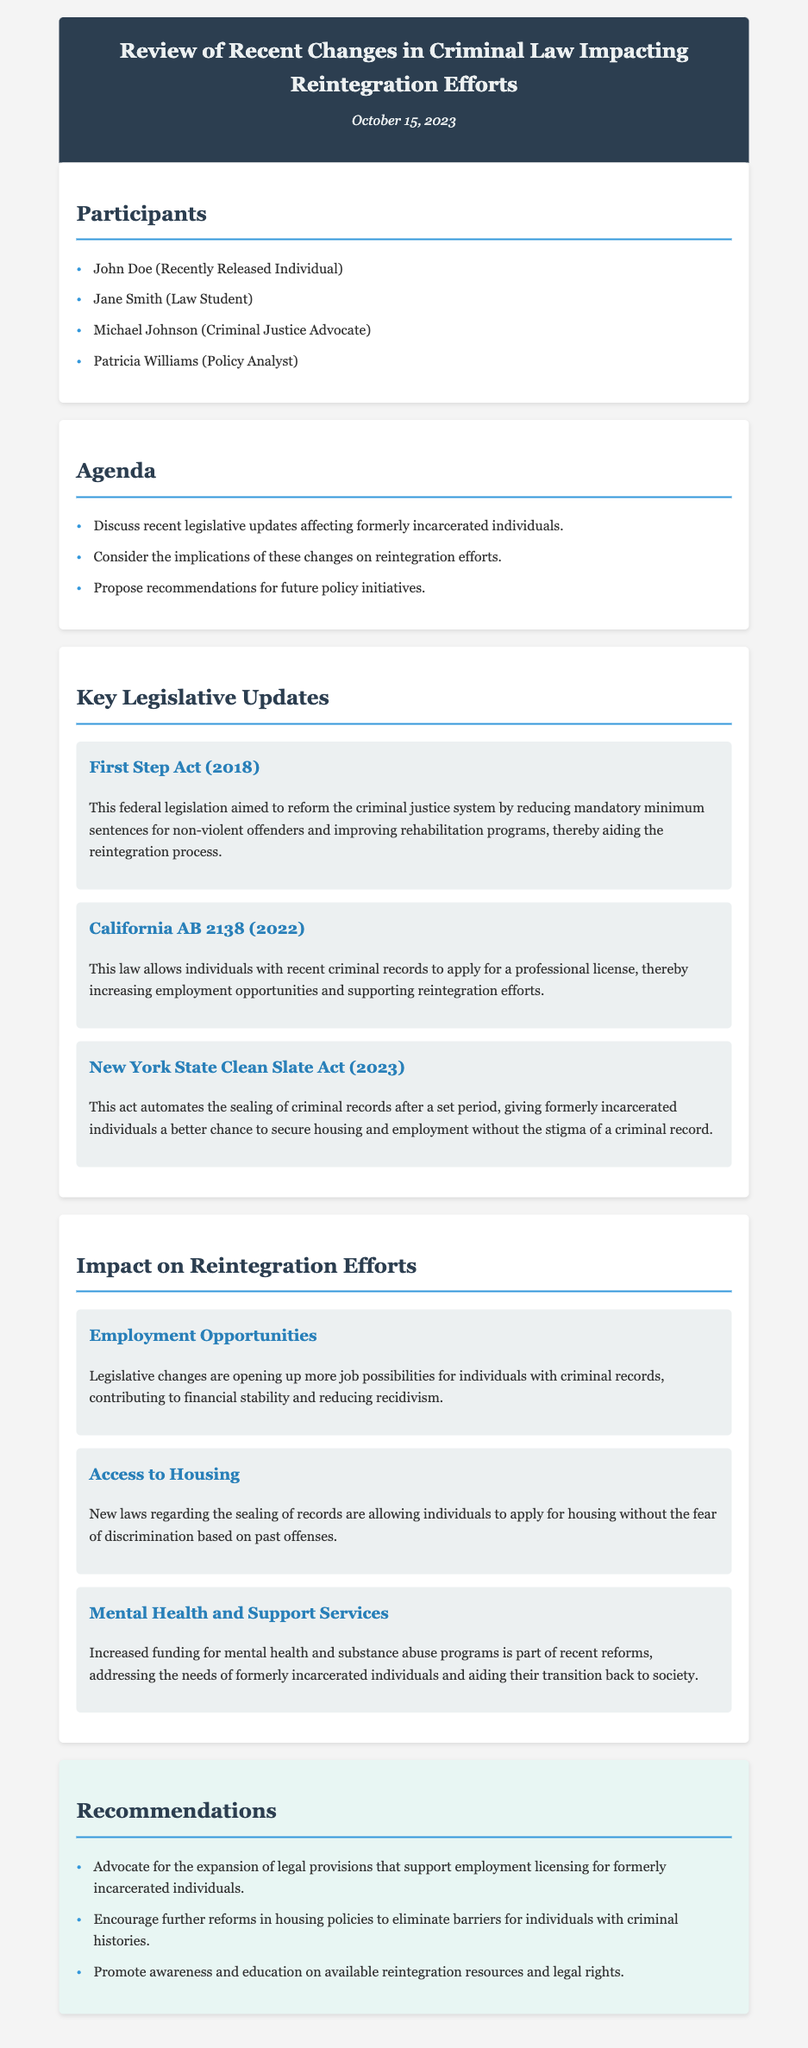What is the date of the meeting? The meeting took place on October 15, 2023, as indicated in the header.
Answer: October 15, 2023 Who is one of the participants listed? The document lists several participants; one of them is John Doe.
Answer: John Doe What is the title of the first legislative update mentioned? The first legislative update is titled "First Step Act (2018)," as seen in the Key Legislative Updates section.
Answer: First Step Act (2018) What significant change does the New York State Clean Slate Act (2023) bring? The act automates the sealing of criminal records, facilitating better opportunities for housing and employment.
Answer: Automates sealing of criminal records What is one of the impacts on employment opportunities stated? Legislative changes are creating more job options for individuals with criminal records.
Answer: More job possibilities What recommendation is made regarding employment licensing? The recommendation advocates for the expansion of legal provisions that support employment licensing.
Answer: Expand legal provisions for employment licensing How many listed participants are present in the meeting? There are four participants listed in the Participants section of the document.
Answer: Four What is a significant area of funding mentioned in the impacts section? Increased funding for mental health and substance abuse programs is noted.
Answer: Mental health and substance abuse programs What is the primary purpose of the meeting according to the agenda? The primary purpose is to discuss recent legislative updates affecting formerly incarcerated individuals.
Answer: Discuss recent legislative updates 